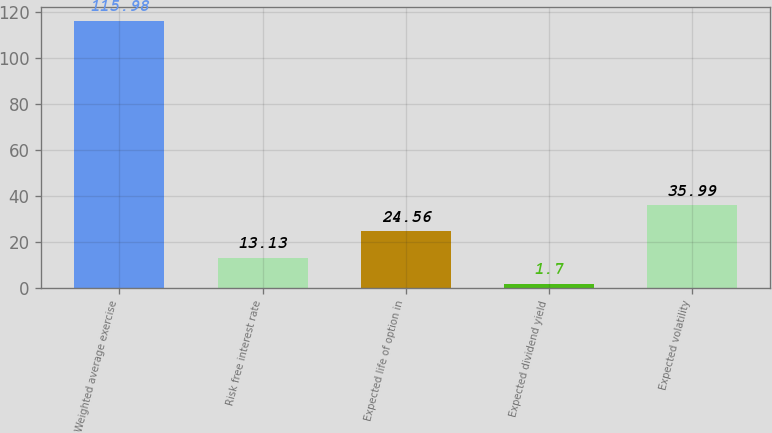<chart> <loc_0><loc_0><loc_500><loc_500><bar_chart><fcel>Weighted average exercise<fcel>Risk free interest rate<fcel>Expected life of option in<fcel>Expected dividend yield<fcel>Expected volatility<nl><fcel>115.98<fcel>13.13<fcel>24.56<fcel>1.7<fcel>35.99<nl></chart> 